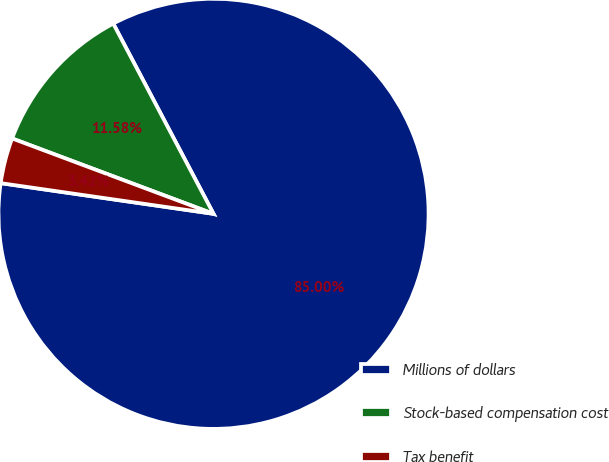Convert chart. <chart><loc_0><loc_0><loc_500><loc_500><pie_chart><fcel>Millions of dollars<fcel>Stock-based compensation cost<fcel>Tax benefit<nl><fcel>85.0%<fcel>11.58%<fcel>3.42%<nl></chart> 